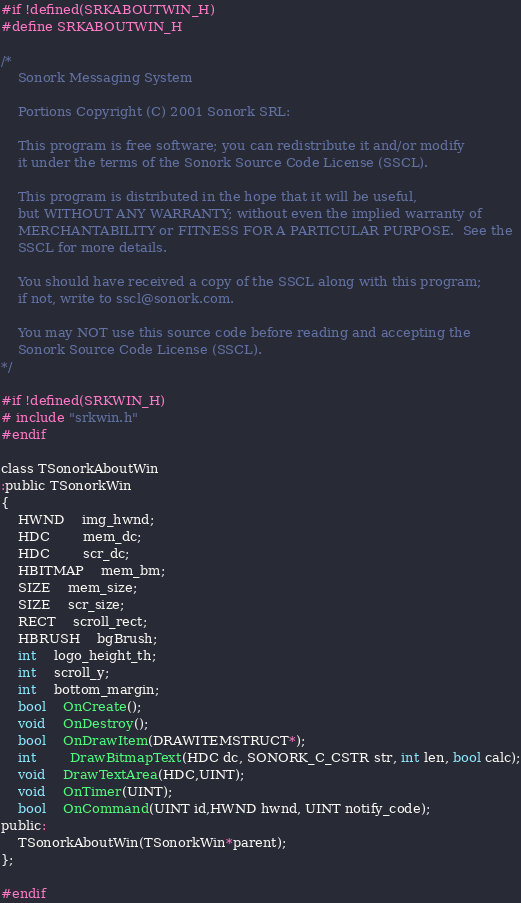<code> <loc_0><loc_0><loc_500><loc_500><_C_>#if !defined(SRKABOUTWIN_H)
#define SRKABOUTWIN_H

/*
	Sonork Messaging System

	Portions Copyright (C) 2001 Sonork SRL:

	This program is free software; you can redistribute it and/or modify
	it under the terms of the Sonork Source Code License (SSCL).

	This program is distributed in the hope that it will be useful,
	but WITHOUT ANY WARRANTY; without even the implied warranty of
	MERCHANTABILITY or FITNESS FOR A PARTICULAR PURPOSE.  See the
	SSCL for more details.

	You should have received a copy of the SSCL	along with this program;
	if not, write to sscl@sonork.com.

	You may NOT use this source code before reading and accepting the
	Sonork Source Code License (SSCL).
*/

#if !defined(SRKWIN_H)
# include "srkwin.h"
#endif

class TSonorkAboutWin
:public TSonorkWin
{
	HWND	img_hwnd;
	HDC		mem_dc;
	HDC		scr_dc;
	HBITMAP	mem_bm;
	SIZE	mem_size;
	SIZE	scr_size;
	RECT	scroll_rect;
	HBRUSH	bgBrush;
	int	logo_height_th;
	int	scroll_y;
	int	bottom_margin;
	bool	OnCreate();
	void 	OnDestroy();
	bool	OnDrawItem(DRAWITEMSTRUCT*);
	int		DrawBitmapText(HDC dc, SONORK_C_CSTR str, int len, bool calc);
	void	DrawTextArea(HDC,UINT);
	void	OnTimer(UINT);
	bool 	OnCommand(UINT id,HWND hwnd, UINT notify_code);
public:
	TSonorkAboutWin(TSonorkWin*parent);
};

#endif</code> 